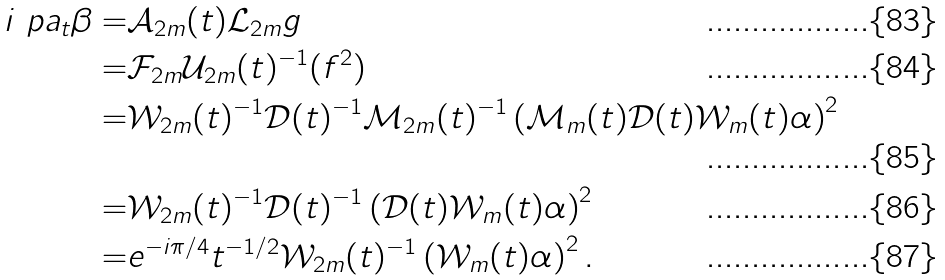<formula> <loc_0><loc_0><loc_500><loc_500>i \ p a _ { t } \beta = & \mathcal { A } _ { 2 m } ( t ) \mathcal { L } _ { 2 m } g \\ = & \mathcal { F } _ { 2 m } \mathcal { U } _ { 2 m } ( t ) ^ { - 1 } ( f ^ { 2 } ) \\ = & \mathcal { W } _ { 2 m } ( t ) ^ { - 1 } \mathcal { D } ( t ) ^ { - 1 } \mathcal { M } _ { 2 m } ( t ) ^ { - 1 } \left ( \mathcal { M } _ { m } ( t ) \mathcal { D } ( t ) \mathcal { W } _ { m } ( t ) \alpha \right ) ^ { 2 } \\ = & \mathcal { W } _ { 2 m } ( t ) ^ { - 1 } \mathcal { D } ( t ) ^ { - 1 } \left ( \mathcal { D } ( t ) \mathcal { W } _ { m } ( t ) \alpha \right ) ^ { 2 } \\ = & e ^ { - i \pi / 4 } t ^ { - 1 / 2 } \mathcal { W } _ { 2 m } ( t ) ^ { - 1 } \left ( \mathcal { W } _ { m } ( t ) \alpha \right ) ^ { 2 } .</formula> 